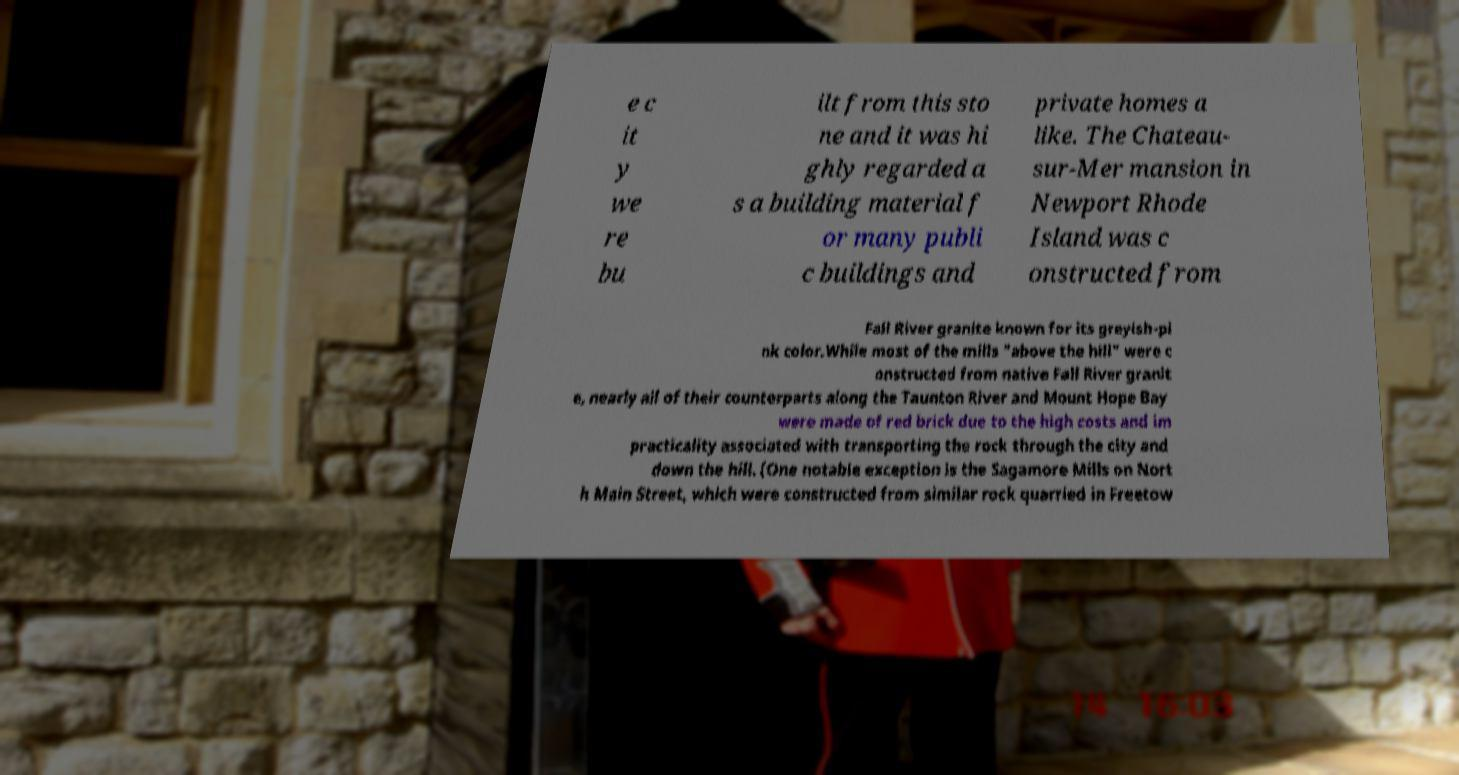I need the written content from this picture converted into text. Can you do that? e c it y we re bu ilt from this sto ne and it was hi ghly regarded a s a building material f or many publi c buildings and private homes a like. The Chateau- sur-Mer mansion in Newport Rhode Island was c onstructed from Fall River granite known for its greyish-pi nk color.While most of the mills "above the hill" were c onstructed from native Fall River granit e, nearly all of their counterparts along the Taunton River and Mount Hope Bay were made of red brick due to the high costs and im practicality associated with transporting the rock through the city and down the hill. (One notable exception is the Sagamore Mills on Nort h Main Street, which were constructed from similar rock quarried in Freetow 